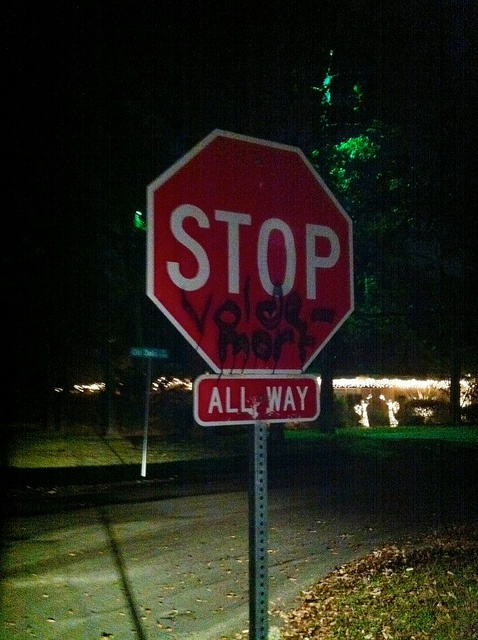Describe the objects in this image and their specific colors. I can see a stop sign in black, maroon, and gray tones in this image. 